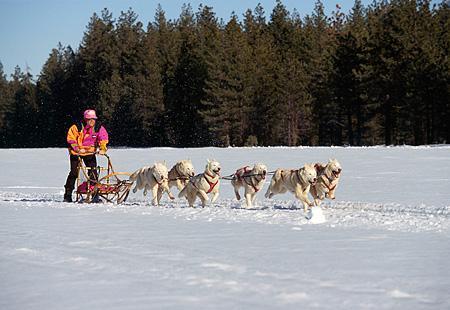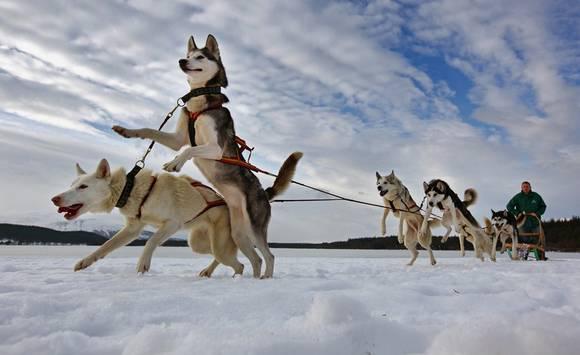The first image is the image on the left, the second image is the image on the right. Examine the images to the left and right. Is the description "The left image contains exactly four sled dogs." accurate? Answer yes or no. No. The first image is the image on the left, the second image is the image on the right. For the images shown, is this caption "Non-snow-covered evergreens and a flat horizon are behind one of the sled dog teams." true? Answer yes or no. Yes. 